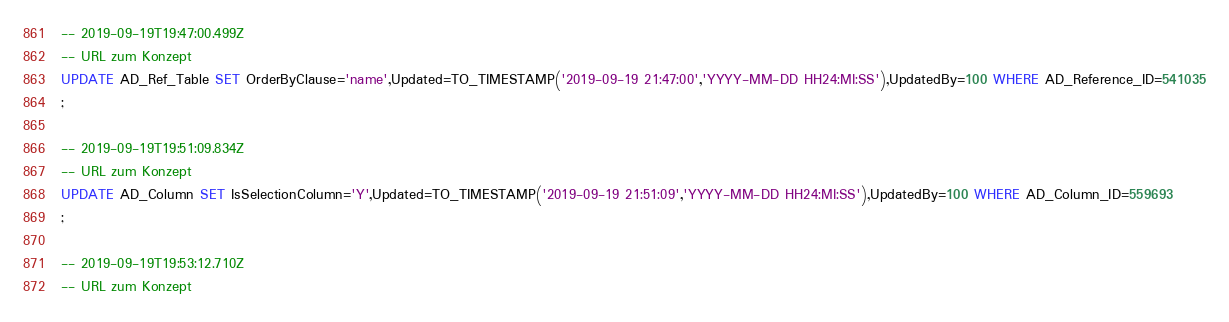Convert code to text. <code><loc_0><loc_0><loc_500><loc_500><_SQL_>-- 2019-09-19T19:47:00.499Z
-- URL zum Konzept
UPDATE AD_Ref_Table SET OrderByClause='name',Updated=TO_TIMESTAMP('2019-09-19 21:47:00','YYYY-MM-DD HH24:MI:SS'),UpdatedBy=100 WHERE AD_Reference_ID=541035
;

-- 2019-09-19T19:51:09.834Z
-- URL zum Konzept
UPDATE AD_Column SET IsSelectionColumn='Y',Updated=TO_TIMESTAMP('2019-09-19 21:51:09','YYYY-MM-DD HH24:MI:SS'),UpdatedBy=100 WHERE AD_Column_ID=559693
;

-- 2019-09-19T19:53:12.710Z
-- URL zum Konzept</code> 